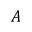Convert formula to latex. <formula><loc_0><loc_0><loc_500><loc_500>A</formula> 